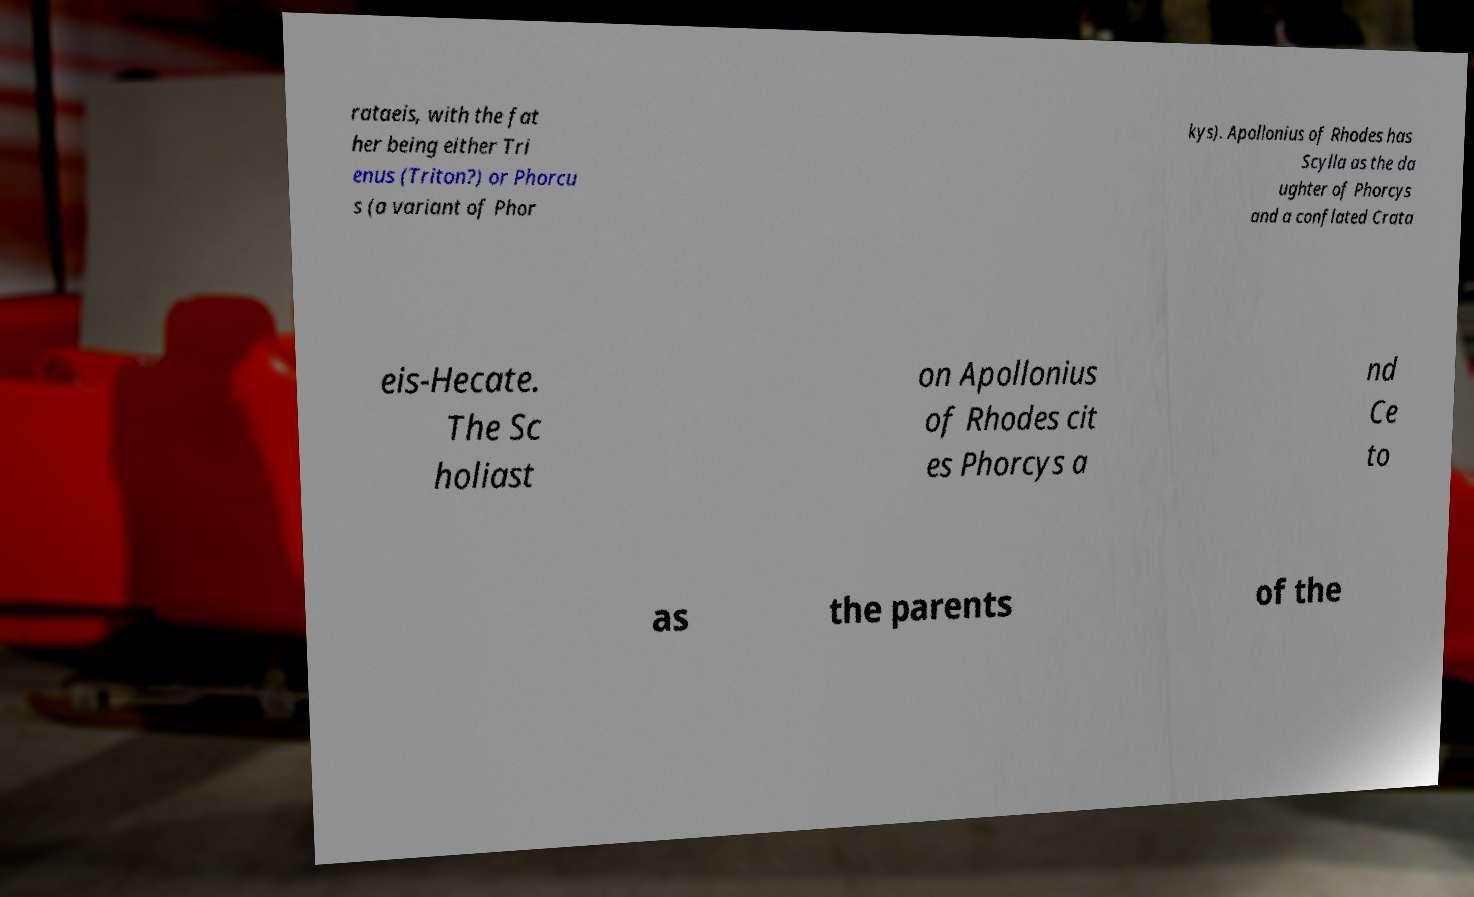Please read and relay the text visible in this image. What does it say? rataeis, with the fat her being either Tri enus (Triton?) or Phorcu s (a variant of Phor kys). Apollonius of Rhodes has Scylla as the da ughter of Phorcys and a conflated Crata eis-Hecate. The Sc holiast on Apollonius of Rhodes cit es Phorcys a nd Ce to as the parents of the 